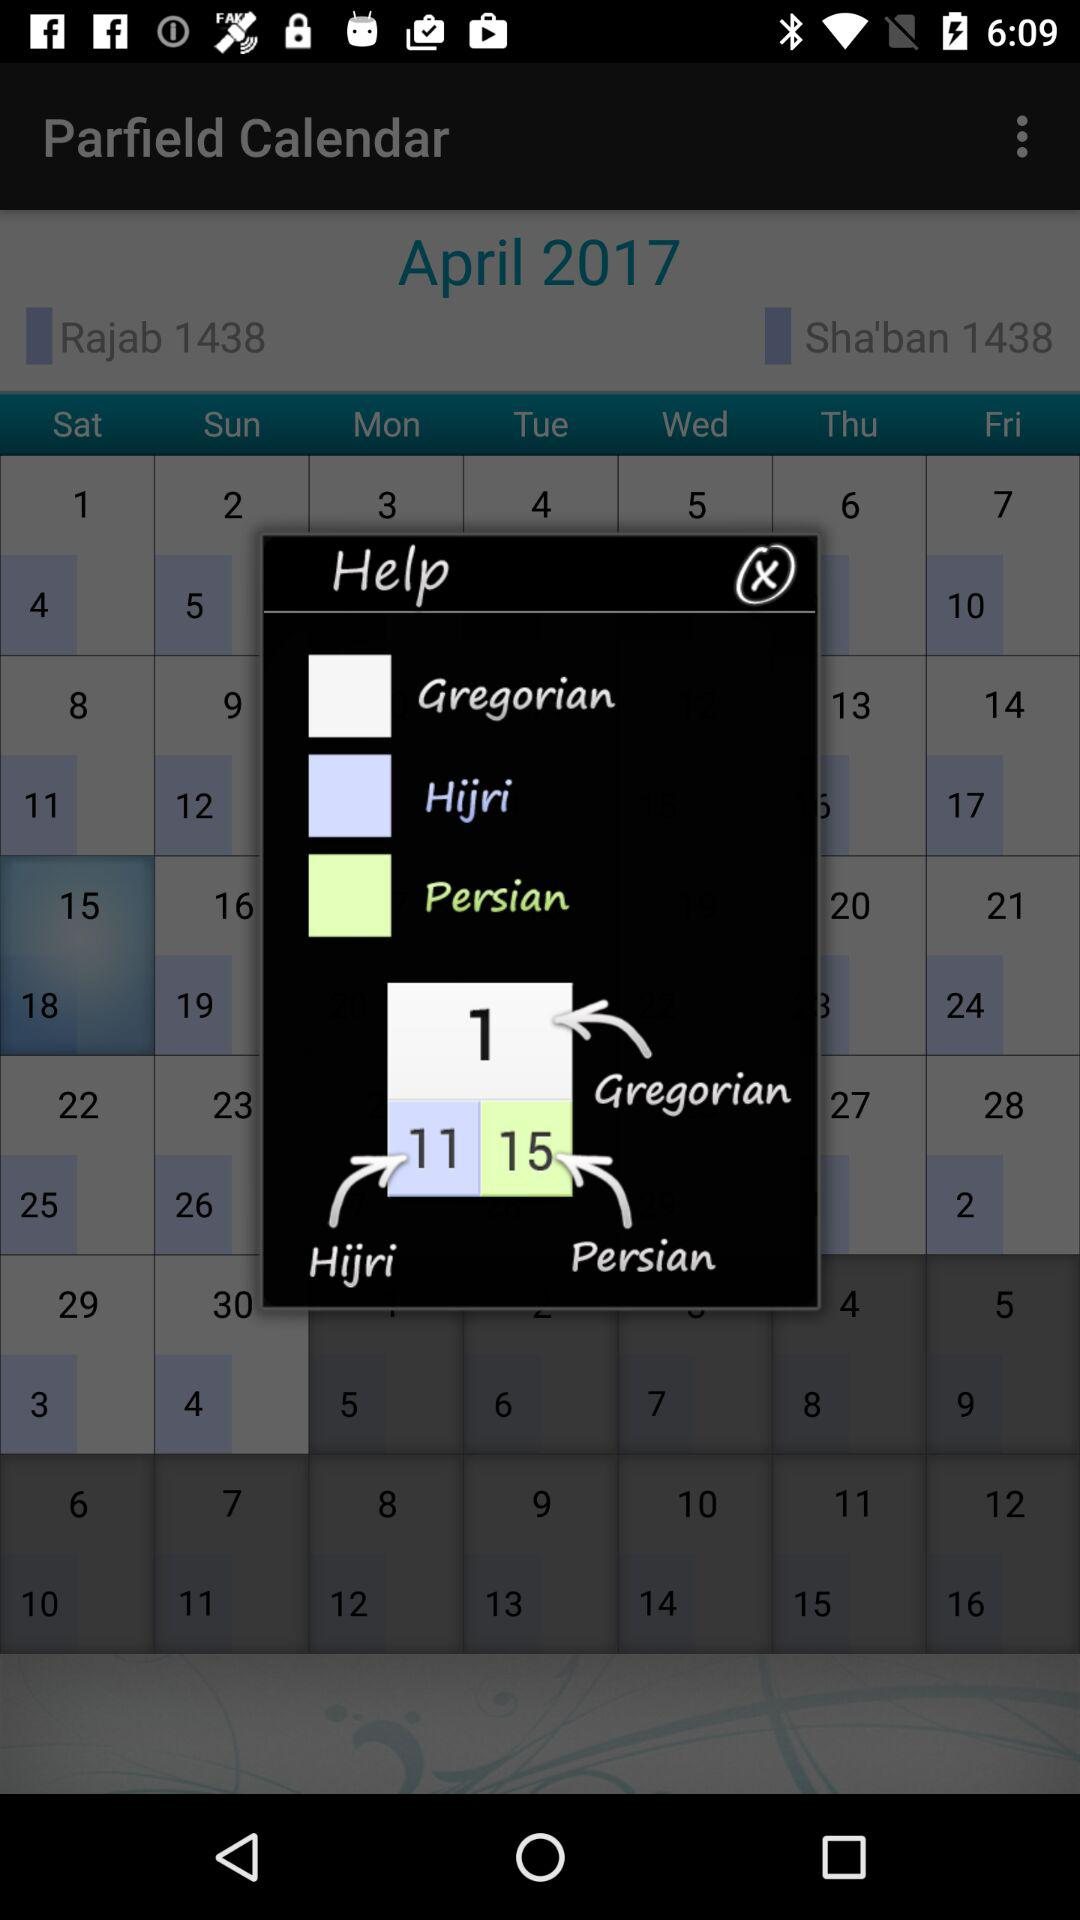How many calendars are displayed?
Answer the question using a single word or phrase. 3 